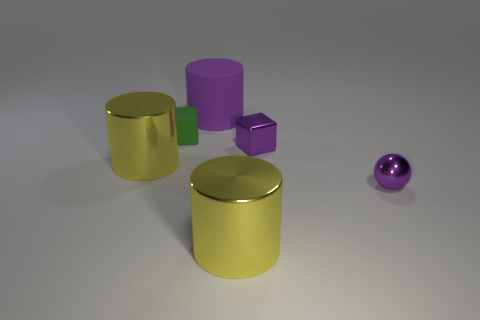Is there anything else that has the same shape as the purple rubber thing?
Your answer should be compact. Yes. Are there more tiny metal objects than small metal blocks?
Make the answer very short. Yes. What number of things are in front of the rubber cylinder and behind the metal block?
Provide a succinct answer. 1. How many purple rubber objects are right of the large metal object on the left side of the big purple matte thing?
Your answer should be compact. 1. There is a yellow shiny object behind the purple ball; is its size the same as the yellow cylinder in front of the purple metallic ball?
Offer a very short reply. Yes. How many yellow things are there?
Offer a terse response. 2. What number of cylinders have the same material as the tiny purple sphere?
Your response must be concise. 2. Are there an equal number of big yellow cylinders that are behind the tiny purple metallic cube and big purple things?
Offer a very short reply. No. There is a big object that is the same color as the tiny metallic cube; what material is it?
Your answer should be compact. Rubber. Do the metal block and the matte object that is right of the tiny green rubber cube have the same size?
Offer a very short reply. No. 